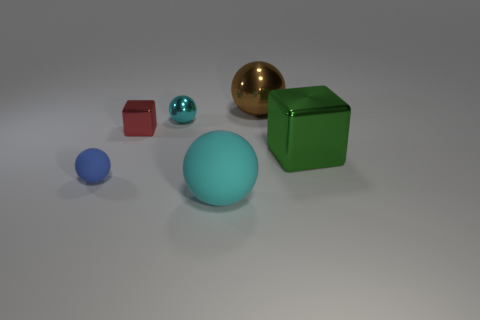Subtract 1 spheres. How many spheres are left? 3 Add 2 blue metal cubes. How many objects exist? 8 Subtract all blocks. How many objects are left? 4 Subtract all red objects. Subtract all big cyan things. How many objects are left? 4 Add 6 blue spheres. How many blue spheres are left? 7 Add 2 tiny brown shiny blocks. How many tiny brown shiny blocks exist? 2 Subtract 0 gray spheres. How many objects are left? 6 